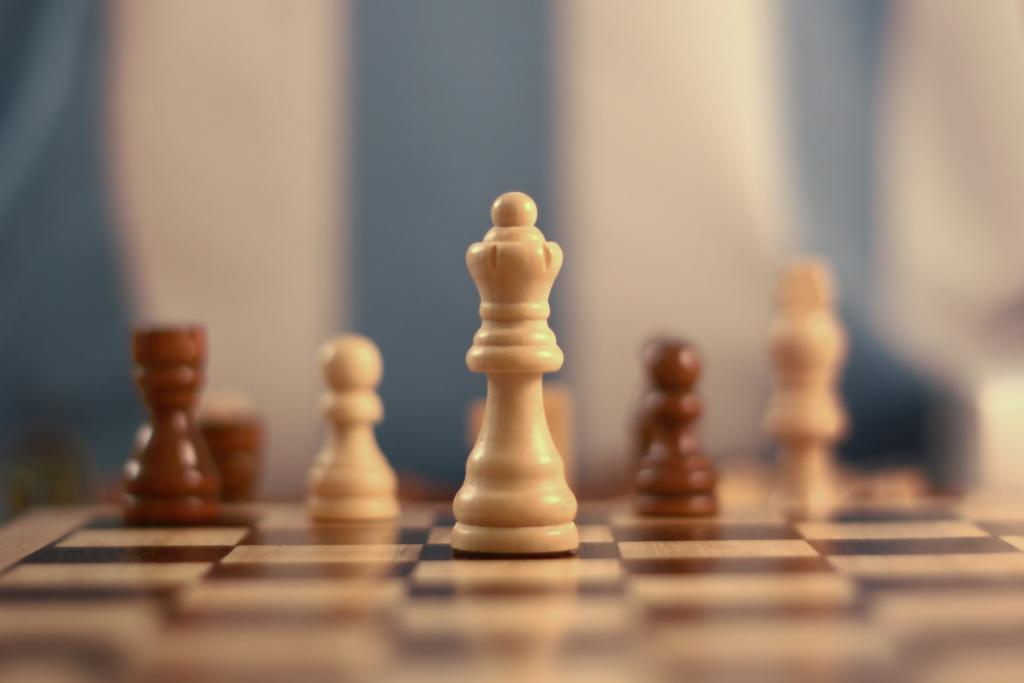What is the main subject of the image? The main subject of the image is a chess board. What is placed on the chess board? There are chess coins on the chess board. Can you describe the background of the image? The background of the image is blurred. What type of knowledge is being shared during the chicken feast in the image? There is no chicken feast or knowledge sharing present in the image; it features a chess board with chess coins. 